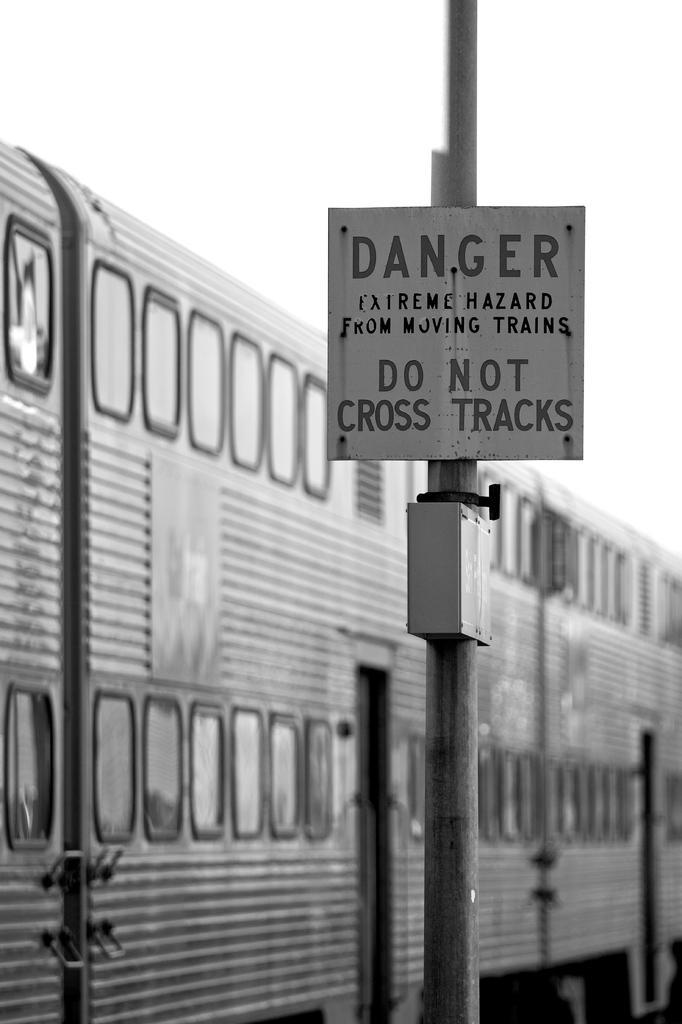In one or two sentences, can you explain what this image depicts? In the middle it is a notice board on the pole. In the left side it looks like a train. 